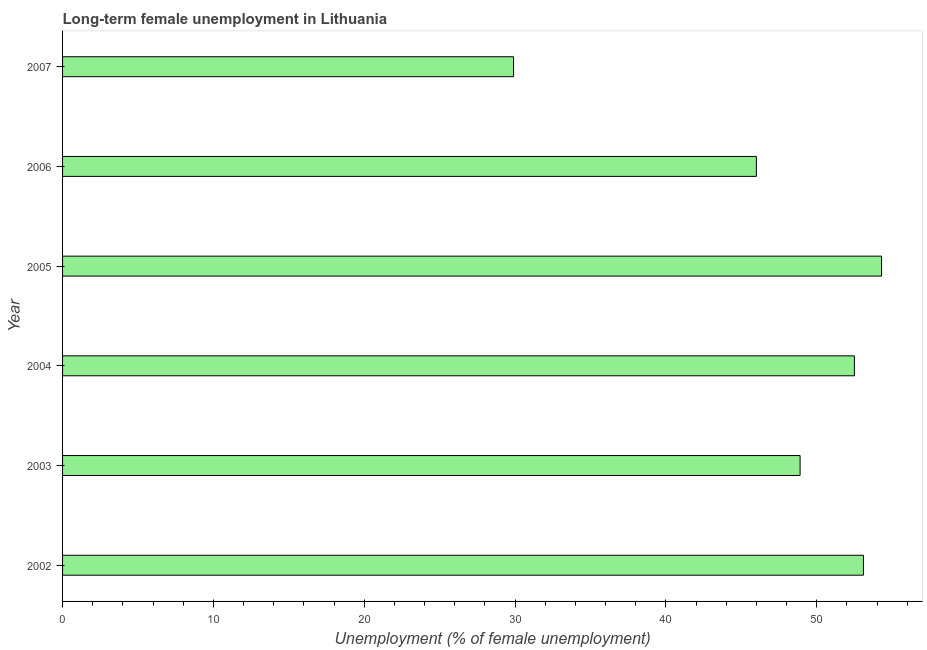Does the graph contain any zero values?
Your response must be concise. No. What is the title of the graph?
Give a very brief answer. Long-term female unemployment in Lithuania. What is the label or title of the X-axis?
Offer a very short reply. Unemployment (% of female unemployment). What is the label or title of the Y-axis?
Provide a short and direct response. Year. What is the long-term female unemployment in 2004?
Ensure brevity in your answer.  52.5. Across all years, what is the maximum long-term female unemployment?
Provide a short and direct response. 54.3. Across all years, what is the minimum long-term female unemployment?
Make the answer very short. 29.9. In which year was the long-term female unemployment maximum?
Provide a short and direct response. 2005. What is the sum of the long-term female unemployment?
Provide a succinct answer. 284.7. What is the average long-term female unemployment per year?
Offer a very short reply. 47.45. What is the median long-term female unemployment?
Offer a very short reply. 50.7. In how many years, is the long-term female unemployment greater than 22 %?
Make the answer very short. 6. Is the long-term female unemployment in 2002 less than that in 2003?
Give a very brief answer. No. Is the sum of the long-term female unemployment in 2004 and 2007 greater than the maximum long-term female unemployment across all years?
Your answer should be compact. Yes. What is the difference between the highest and the lowest long-term female unemployment?
Offer a very short reply. 24.4. How many bars are there?
Provide a succinct answer. 6. Are all the bars in the graph horizontal?
Your answer should be very brief. Yes. How many years are there in the graph?
Your answer should be very brief. 6. What is the difference between two consecutive major ticks on the X-axis?
Your answer should be very brief. 10. What is the Unemployment (% of female unemployment) in 2002?
Provide a short and direct response. 53.1. What is the Unemployment (% of female unemployment) of 2003?
Offer a terse response. 48.9. What is the Unemployment (% of female unemployment) in 2004?
Your answer should be compact. 52.5. What is the Unemployment (% of female unemployment) in 2005?
Make the answer very short. 54.3. What is the Unemployment (% of female unemployment) in 2007?
Offer a terse response. 29.9. What is the difference between the Unemployment (% of female unemployment) in 2002 and 2004?
Your answer should be compact. 0.6. What is the difference between the Unemployment (% of female unemployment) in 2002 and 2006?
Offer a very short reply. 7.1. What is the difference between the Unemployment (% of female unemployment) in 2002 and 2007?
Offer a terse response. 23.2. What is the difference between the Unemployment (% of female unemployment) in 2003 and 2007?
Make the answer very short. 19. What is the difference between the Unemployment (% of female unemployment) in 2004 and 2006?
Provide a succinct answer. 6.5. What is the difference between the Unemployment (% of female unemployment) in 2004 and 2007?
Provide a short and direct response. 22.6. What is the difference between the Unemployment (% of female unemployment) in 2005 and 2007?
Ensure brevity in your answer.  24.4. What is the ratio of the Unemployment (% of female unemployment) in 2002 to that in 2003?
Offer a terse response. 1.09. What is the ratio of the Unemployment (% of female unemployment) in 2002 to that in 2004?
Make the answer very short. 1.01. What is the ratio of the Unemployment (% of female unemployment) in 2002 to that in 2005?
Keep it short and to the point. 0.98. What is the ratio of the Unemployment (% of female unemployment) in 2002 to that in 2006?
Offer a very short reply. 1.15. What is the ratio of the Unemployment (% of female unemployment) in 2002 to that in 2007?
Your answer should be compact. 1.78. What is the ratio of the Unemployment (% of female unemployment) in 2003 to that in 2005?
Keep it short and to the point. 0.9. What is the ratio of the Unemployment (% of female unemployment) in 2003 to that in 2006?
Provide a succinct answer. 1.06. What is the ratio of the Unemployment (% of female unemployment) in 2003 to that in 2007?
Keep it short and to the point. 1.64. What is the ratio of the Unemployment (% of female unemployment) in 2004 to that in 2005?
Make the answer very short. 0.97. What is the ratio of the Unemployment (% of female unemployment) in 2004 to that in 2006?
Your response must be concise. 1.14. What is the ratio of the Unemployment (% of female unemployment) in 2004 to that in 2007?
Keep it short and to the point. 1.76. What is the ratio of the Unemployment (% of female unemployment) in 2005 to that in 2006?
Make the answer very short. 1.18. What is the ratio of the Unemployment (% of female unemployment) in 2005 to that in 2007?
Provide a short and direct response. 1.82. What is the ratio of the Unemployment (% of female unemployment) in 2006 to that in 2007?
Provide a short and direct response. 1.54. 